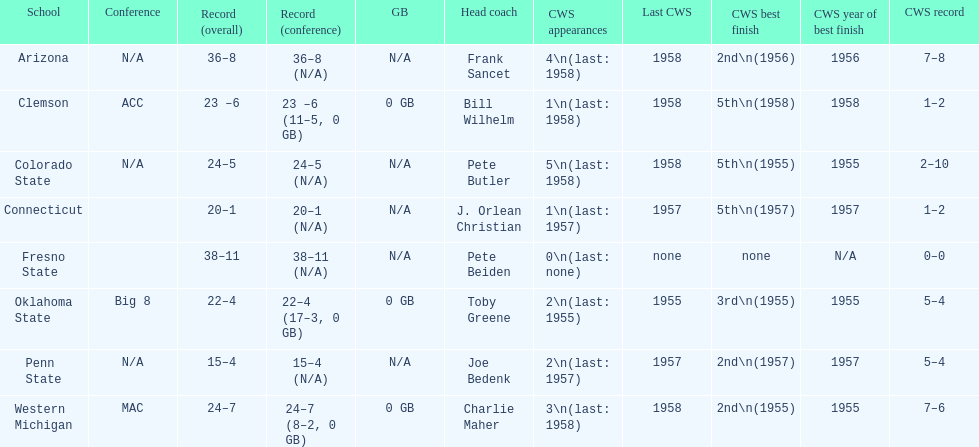What were scores for each school in the 1959 ncaa tournament? 36–8 (N/A), 23 –6 (11–5, 0 GB), 24–5 (N/A), 20–1 (N/A), 38–11 (N/A), 22–4 (17–3, 0 GB), 15–4 (N/A), 24–7 (8–2, 0 GB). What score did not have at least 16 wins? 15–4 (N/A). What team earned this score? Penn State. 